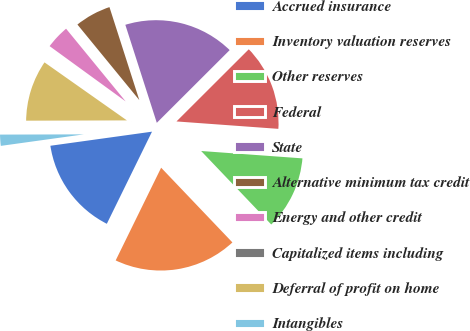Convert chart to OTSL. <chart><loc_0><loc_0><loc_500><loc_500><pie_chart><fcel>Accrued insurance<fcel>Inventory valuation reserves<fcel>Other reserves<fcel>Federal<fcel>State<fcel>Alternative minimum tax credit<fcel>Energy and other credit<fcel>Capitalized items including<fcel>Deferral of profit on home<fcel>Intangibles<nl><fcel>15.55%<fcel>19.38%<fcel>11.72%<fcel>13.64%<fcel>17.46%<fcel>5.98%<fcel>4.07%<fcel>0.24%<fcel>9.81%<fcel>2.15%<nl></chart> 